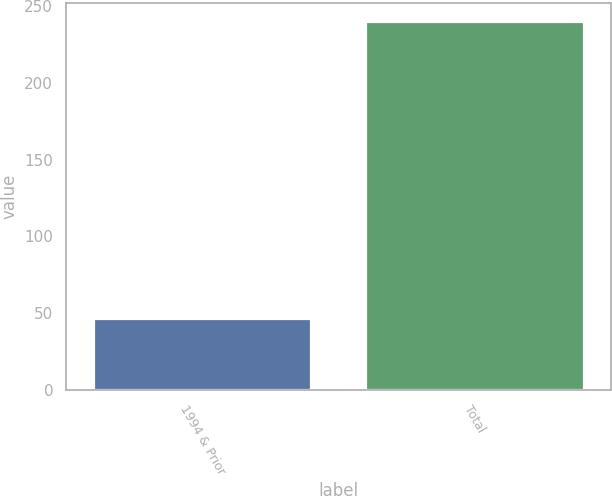Convert chart. <chart><loc_0><loc_0><loc_500><loc_500><bar_chart><fcel>1994 & Prior<fcel>Total<nl><fcel>46<fcel>240<nl></chart> 